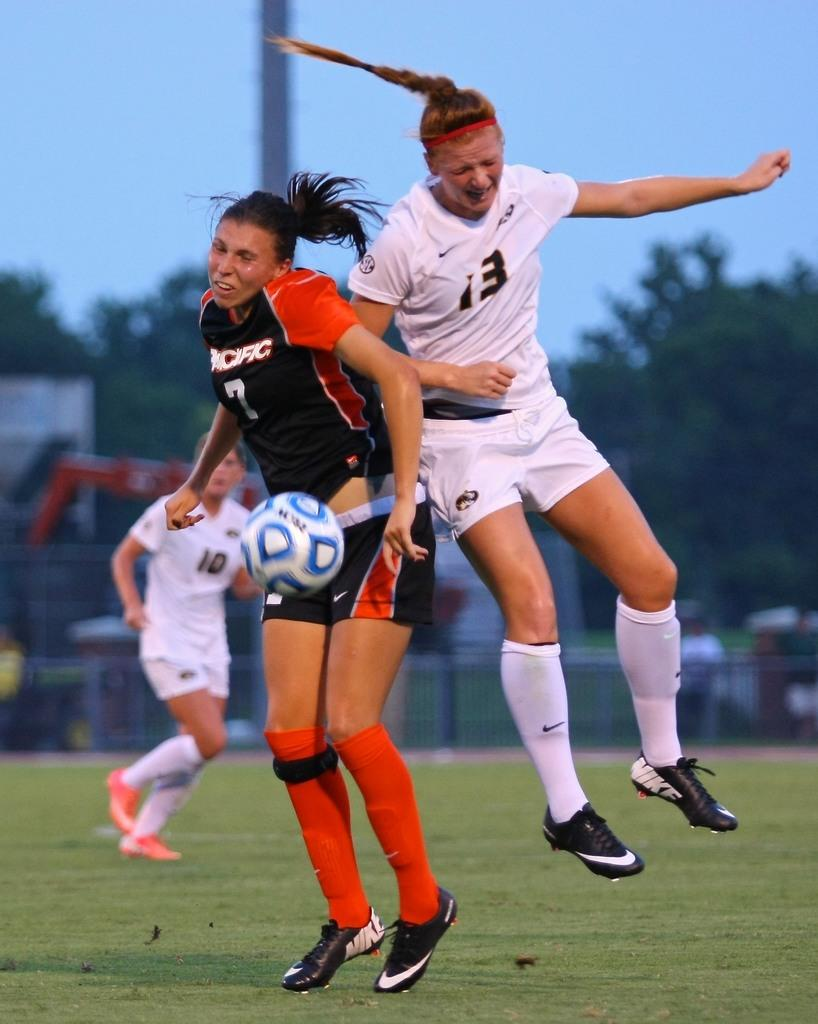<image>
Render a clear and concise summary of the photo. Number 13 in white has jumped high into the air. 